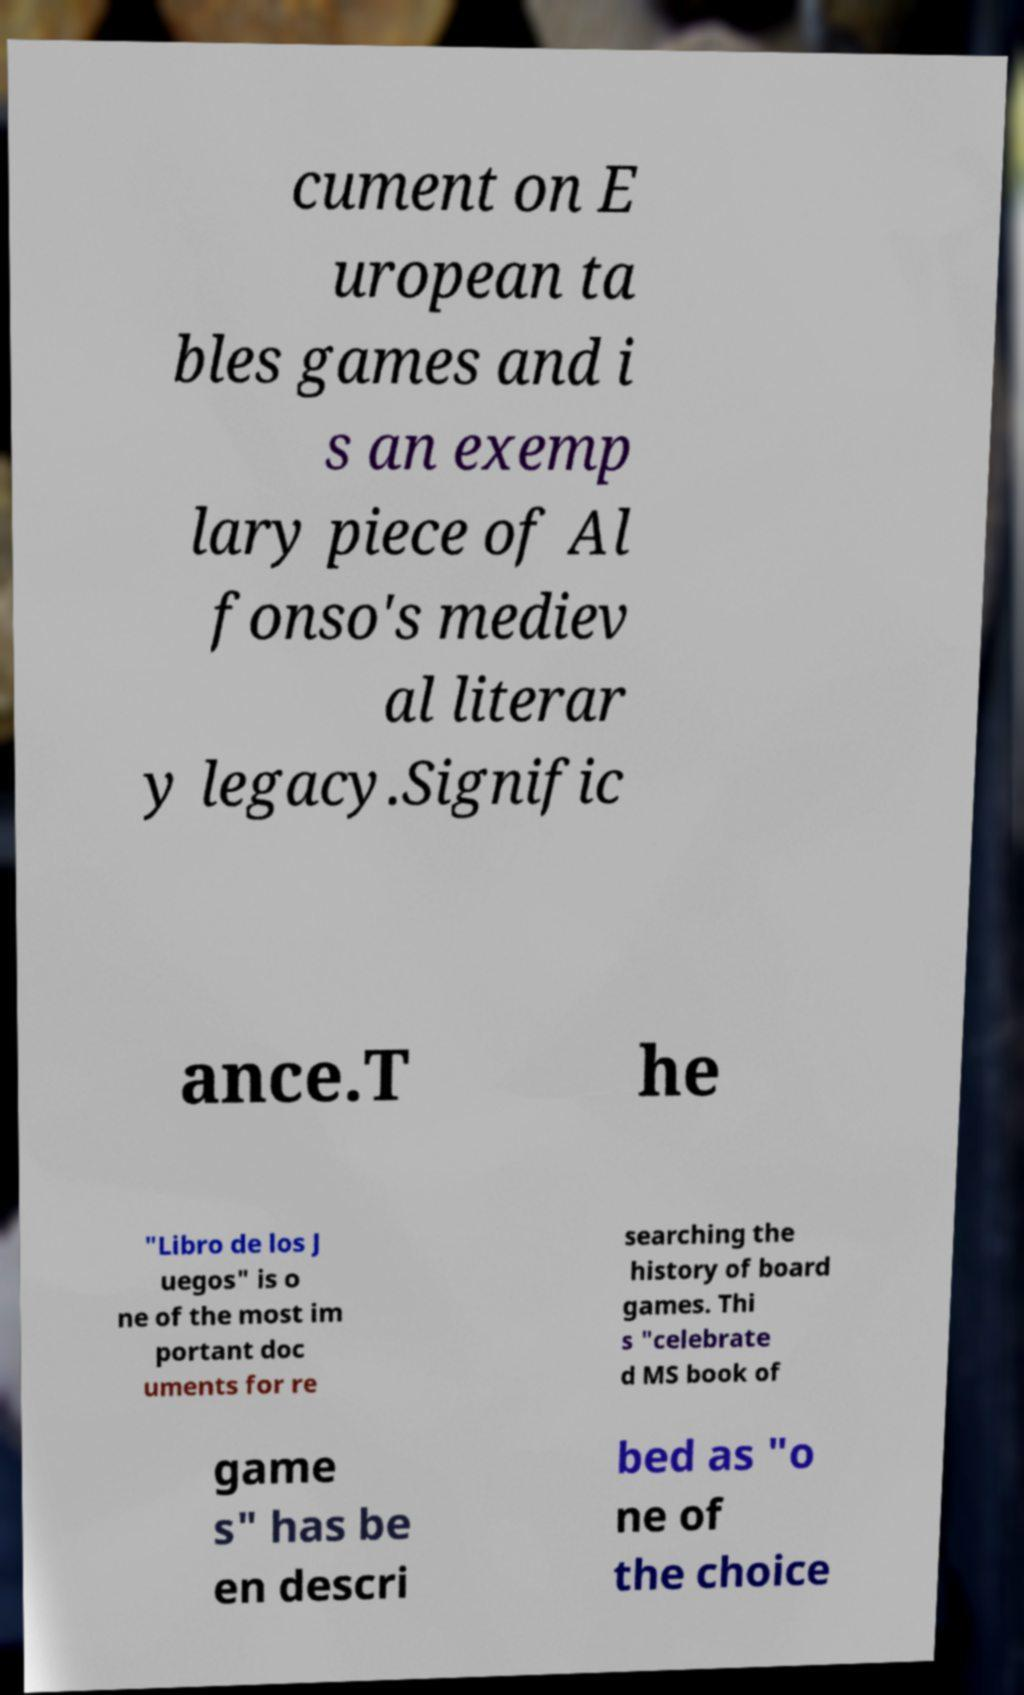Could you extract and type out the text from this image? cument on E uropean ta bles games and i s an exemp lary piece of Al fonso's mediev al literar y legacy.Signific ance.T he "Libro de los J uegos" is o ne of the most im portant doc uments for re searching the history of board games. Thi s "celebrate d MS book of game s" has be en descri bed as "o ne of the choice 